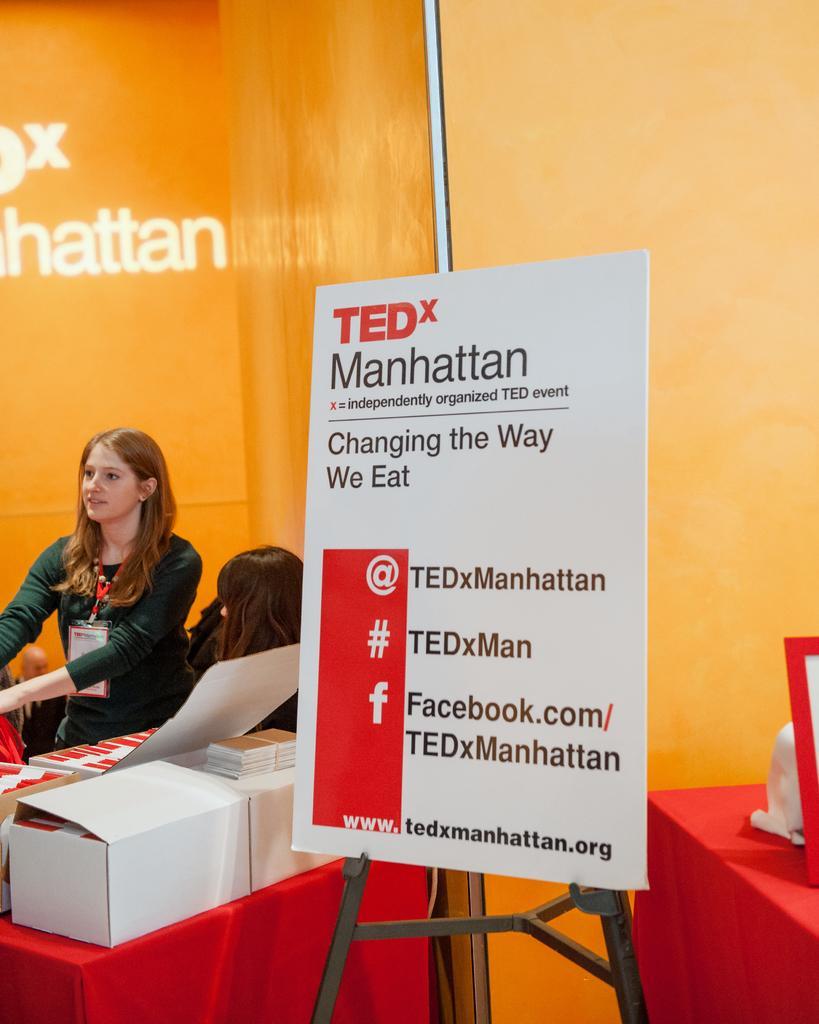Describe this image in one or two sentences. In this picture there are two ladies those who are sitting at the left side of the image and there is a poster which is placed on a holder on which it is written as changing the way we eat. 